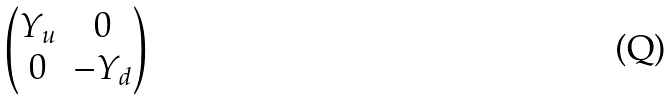<formula> <loc_0><loc_0><loc_500><loc_500>\begin{pmatrix} Y _ { u } & 0 \\ 0 & - Y _ { d } \\ \end{pmatrix}</formula> 